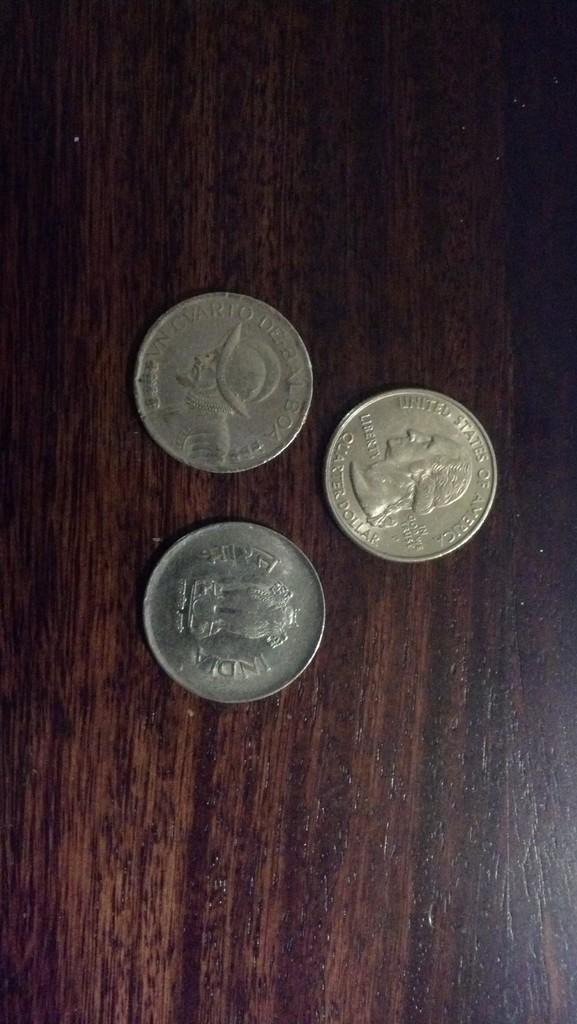<image>
Write a terse but informative summary of the picture. Three coins, including one from the United States of America, are on a wooden surface. 